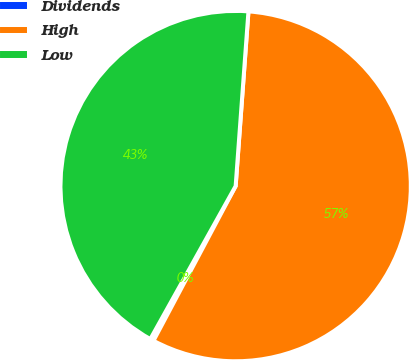Convert chart to OTSL. <chart><loc_0><loc_0><loc_500><loc_500><pie_chart><fcel>Dividends<fcel>High<fcel>Low<nl><fcel>0.32%<fcel>56.61%<fcel>43.07%<nl></chart> 